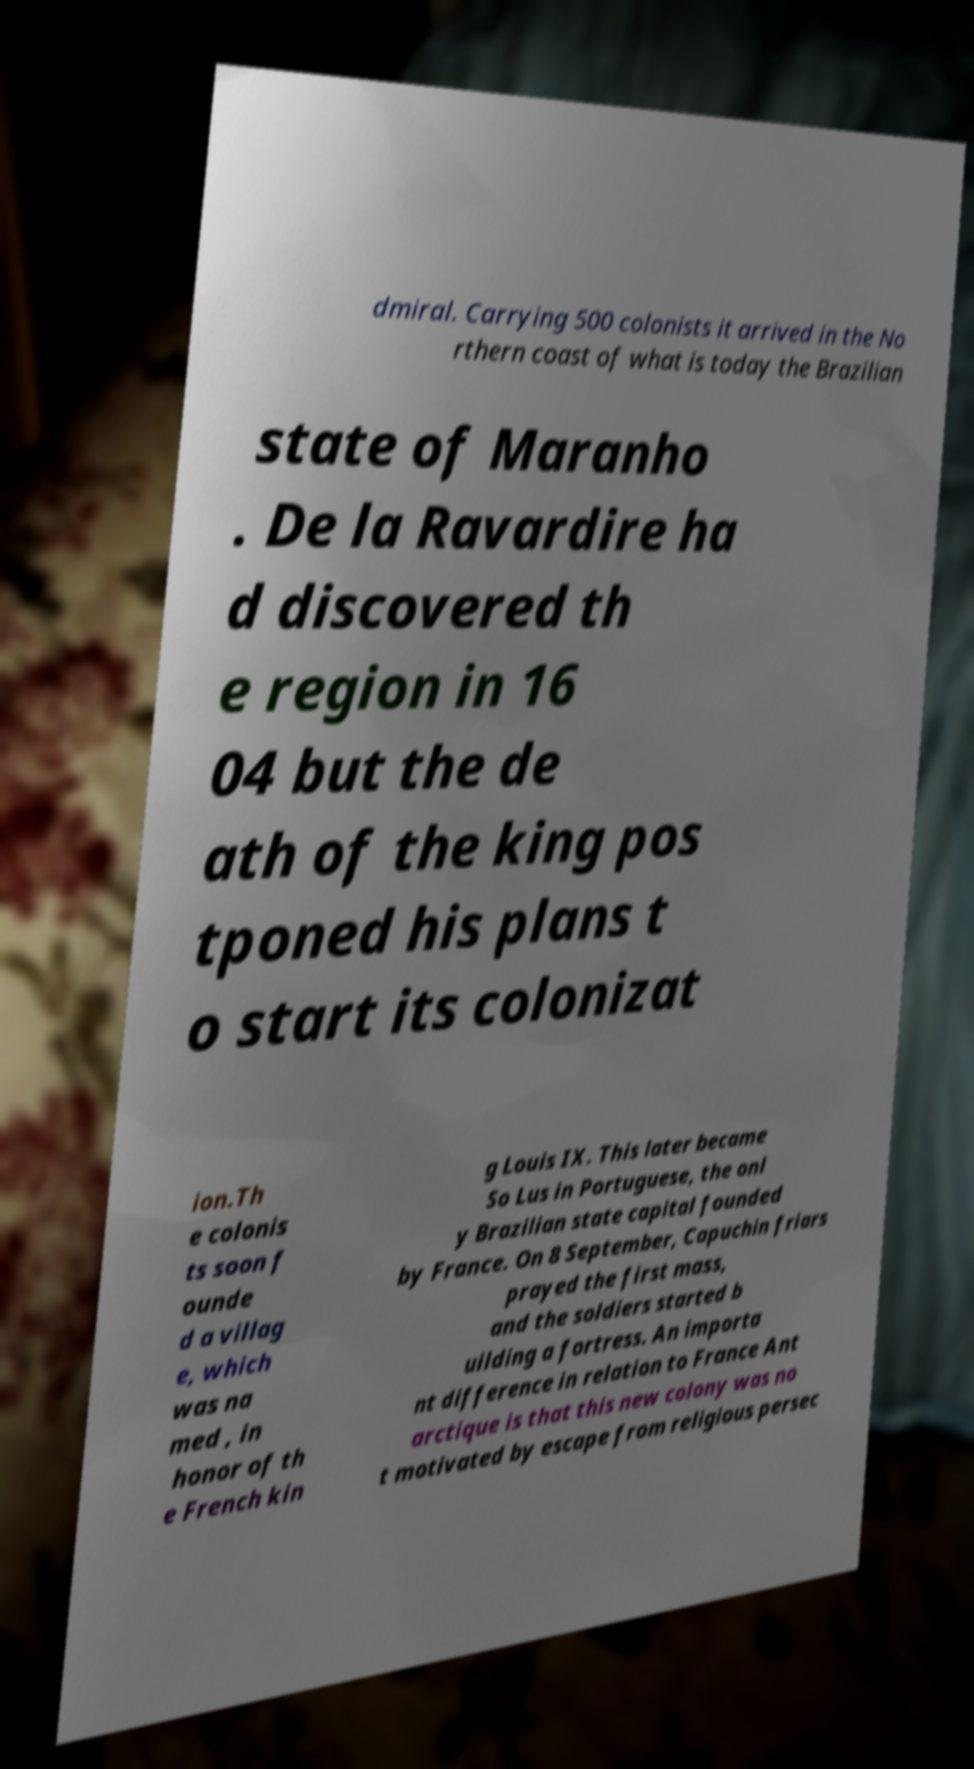Can you read and provide the text displayed in the image?This photo seems to have some interesting text. Can you extract and type it out for me? dmiral. Carrying 500 colonists it arrived in the No rthern coast of what is today the Brazilian state of Maranho . De la Ravardire ha d discovered th e region in 16 04 but the de ath of the king pos tponed his plans t o start its colonizat ion.Th e colonis ts soon f ounde d a villag e, which was na med , in honor of th e French kin g Louis IX. This later became So Lus in Portuguese, the onl y Brazilian state capital founded by France. On 8 September, Capuchin friars prayed the first mass, and the soldiers started b uilding a fortress. An importa nt difference in relation to France Ant arctique is that this new colony was no t motivated by escape from religious persec 